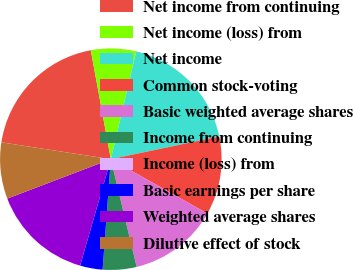<chart> <loc_0><loc_0><loc_500><loc_500><pie_chart><fcel>Net income from continuing<fcel>Net income (loss) from<fcel>Net income<fcel>Common stock-voting<fcel>Basic weighted average shares<fcel>Income from continuing<fcel>Income (loss) from<fcel>Basic earnings per share<fcel>Weighted average shares<fcel>Dilutive effect of stock<nl><fcel>19.67%<fcel>6.58%<fcel>18.03%<fcel>11.45%<fcel>13.09%<fcel>4.93%<fcel>0.0%<fcel>3.29%<fcel>14.74%<fcel>8.22%<nl></chart> 